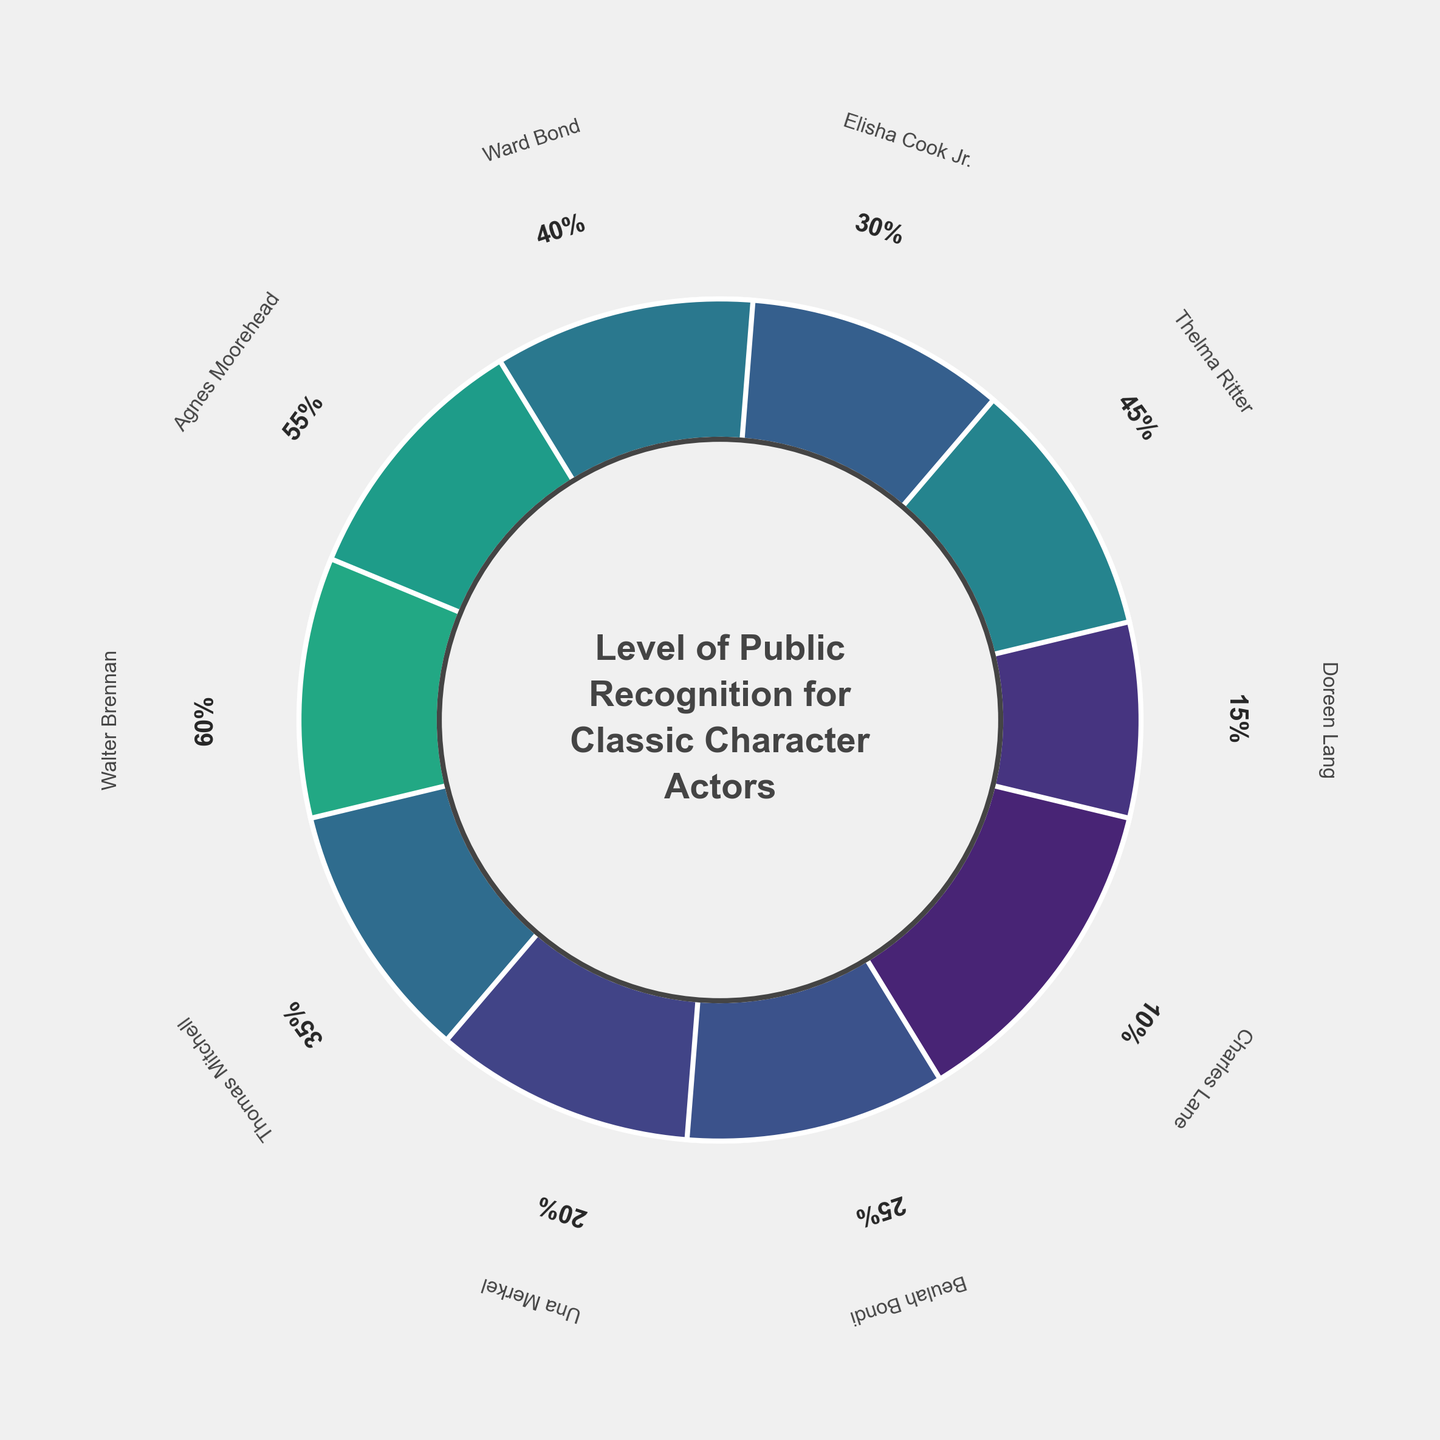what's the title of the figure? The title of the figure is written in bold text at the center circle of the gauge chart. It reads "Level of Public Recognition for Classic Character Actors".
Answer: Level of Public Recognition for Classic Character Actors which actor has the highest public recognition? By looking at the different colored sections (wedges) around the chart, we can see that Walter Brennan has the highest recognition percentage with the wedge corresponding to 60%.
Answer: Walter Brennan how many actors have a public recognition percentage less than 30%? By examining the numerical percentages provided next to each actor's section, we count the actors with recognition percentages less than 30. These actors are Doreen Lang (15%), Una Merkel (20%), Beulah Bondi (25%), and Charles Lane (10%).
Answer: 4 what’s the difference in recognition percentage between Agnes Moorehead and Thomas Mitchell? Find Agnes Moorehead's percentage (55%) and Thomas Mitchell's percentage (35%). Subtract the latter from the former to get the difference: 55% - 35% = 20%.
Answer: 20% which actor has a 45% public recognition and what is the color of the corresponding wedge? By looking at the percentage next to each actor’s name, we see that Thelma Ritter has a 45% recognition. The color can be identified as a shade of the color map used, such as viridis, corresponding roughly to the percentage. This usually appears as a greenish-blue hue.
Answer: Thelma Ritter, greenish-blue compared to Ward Bond, is Doreen Lang more or less recognized? By how much? Ward Bond's recognition percentage is 40%, while Doreen Lang's is 15%. By subtracting the two, we see that Doreen Lang is less recognized by 25% (40% - 15%).
Answer: Less, 25% what is the average recognition percentage among all actors? Sum all the recognition percentages: 15 + 45 + 30 + 40 + 55 + 60 + 35 + 20 + 25 + 10 = 335. There are 10 actors, so divide the total by 10: 335 / 10 = 33.5%.
Answer: 33.5% are there more actors with recognition percentages above or below 30%? Count the number of actors with percentages above 30: Thelma Ritter (45%), Elisha Cook Jr. (30% is considered equal), Ward Bond (40%), Agnes Moorehead (55%), Walter Brennan (60%), Thomas Mitchell (35%). There are 6 actors above 30%. Hist the number below 30%: Doreen Lang (15%), Una Merkel (20%), Beulah Bondi (25%), Charles Lane (10%). There are 4 actors below 30%.
Answer: Above if we were to rank the actors by their public recognition, which position would Thomas Mitchell have? List the actors by their recognition percentages in descending order: Walter Brennan (60%), Agnes Moorehead (55%), Thelma Ritter (45%), Ward Bond (40%), Thomas Mitchell (35%). Thomas Mitchell would be in the 5th position.
Answer: 5th 